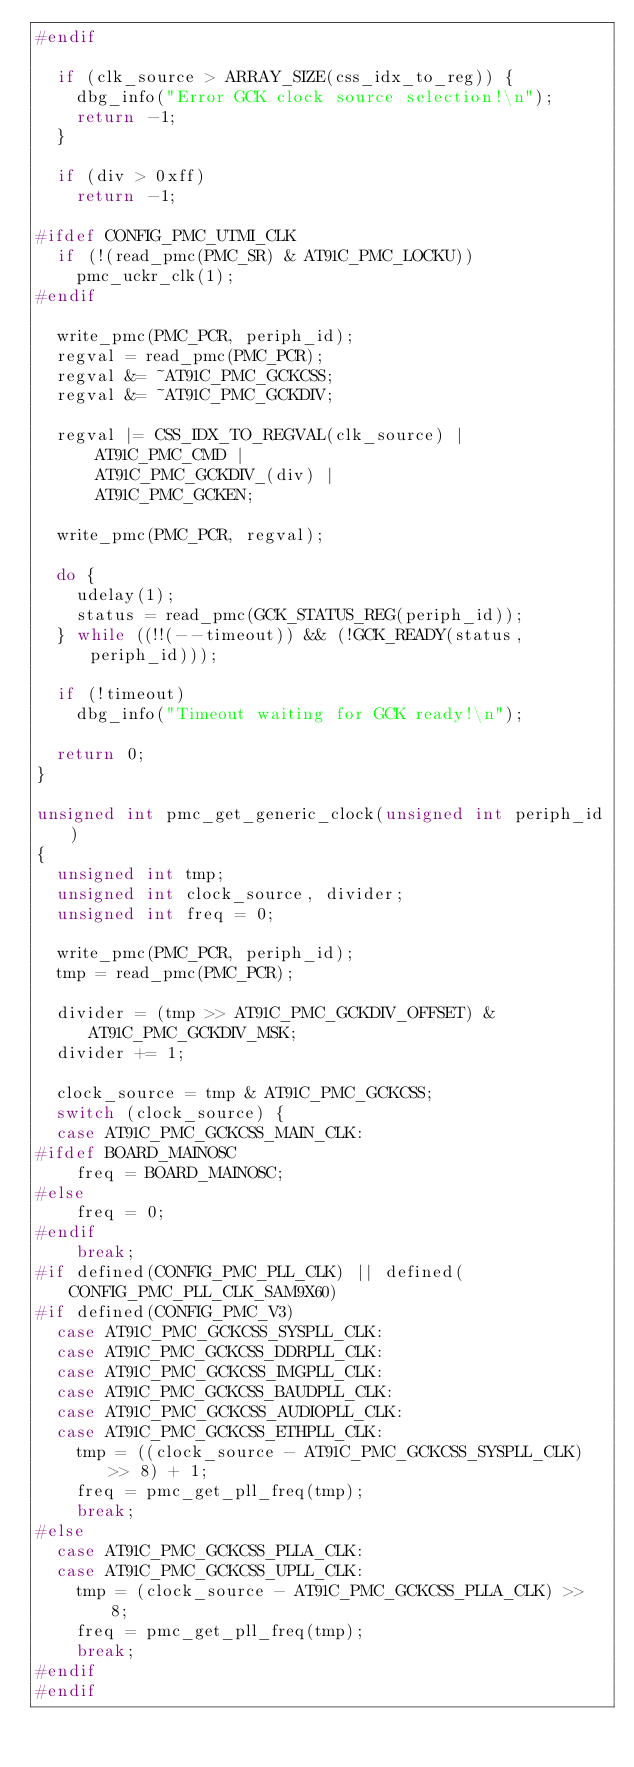Convert code to text. <code><loc_0><loc_0><loc_500><loc_500><_C_>#endif

	if (clk_source > ARRAY_SIZE(css_idx_to_reg)) {
		dbg_info("Error GCK clock source selection!\n");
		return -1;
	}

	if (div > 0xff)
		return -1;

#ifdef CONFIG_PMC_UTMI_CLK
	if (!(read_pmc(PMC_SR) & AT91C_PMC_LOCKU))
		pmc_uckr_clk(1);
#endif

	write_pmc(PMC_PCR, periph_id);
	regval = read_pmc(PMC_PCR);
	regval &= ~AT91C_PMC_GCKCSS;
	regval &= ~AT91C_PMC_GCKDIV;

	regval |= CSS_IDX_TO_REGVAL(clk_source) |
		  AT91C_PMC_CMD |
		  AT91C_PMC_GCKDIV_(div) |
		  AT91C_PMC_GCKEN;

	write_pmc(PMC_PCR, regval);

	do {
		udelay(1);
		status = read_pmc(GCK_STATUS_REG(periph_id));
	} while ((!!(--timeout)) && (!GCK_READY(status, periph_id)));

	if (!timeout)
		dbg_info("Timeout waiting for GCK ready!\n");

	return 0;
}

unsigned int pmc_get_generic_clock(unsigned int periph_id)
{
	unsigned int tmp;
	unsigned int clock_source, divider;
	unsigned int freq = 0;

	write_pmc(PMC_PCR, periph_id);
	tmp = read_pmc(PMC_PCR);

	divider = (tmp >> AT91C_PMC_GCKDIV_OFFSET) & AT91C_PMC_GCKDIV_MSK;
	divider += 1;

	clock_source = tmp & AT91C_PMC_GCKCSS;
	switch (clock_source) {
	case AT91C_PMC_GCKCSS_MAIN_CLK:
#ifdef BOARD_MAINOSC
		freq = BOARD_MAINOSC;
#else
		freq = 0;
#endif
		break;
#if defined(CONFIG_PMC_PLL_CLK) || defined(CONFIG_PMC_PLL_CLK_SAM9X60)
#if defined(CONFIG_PMC_V3)
	case AT91C_PMC_GCKCSS_SYSPLL_CLK:
	case AT91C_PMC_GCKCSS_DDRPLL_CLK:
	case AT91C_PMC_GCKCSS_IMGPLL_CLK:
	case AT91C_PMC_GCKCSS_BAUDPLL_CLK:
	case AT91C_PMC_GCKCSS_AUDIOPLL_CLK:
	case AT91C_PMC_GCKCSS_ETHPLL_CLK:
		tmp = ((clock_source - AT91C_PMC_GCKCSS_SYSPLL_CLK) >> 8) + 1;
		freq = pmc_get_pll_freq(tmp);
		break;
#else
	case AT91C_PMC_GCKCSS_PLLA_CLK:
	case AT91C_PMC_GCKCSS_UPLL_CLK:
		tmp = (clock_source - AT91C_PMC_GCKCSS_PLLA_CLK) >> 8;
		freq = pmc_get_pll_freq(tmp);
		break;
#endif
#endif</code> 